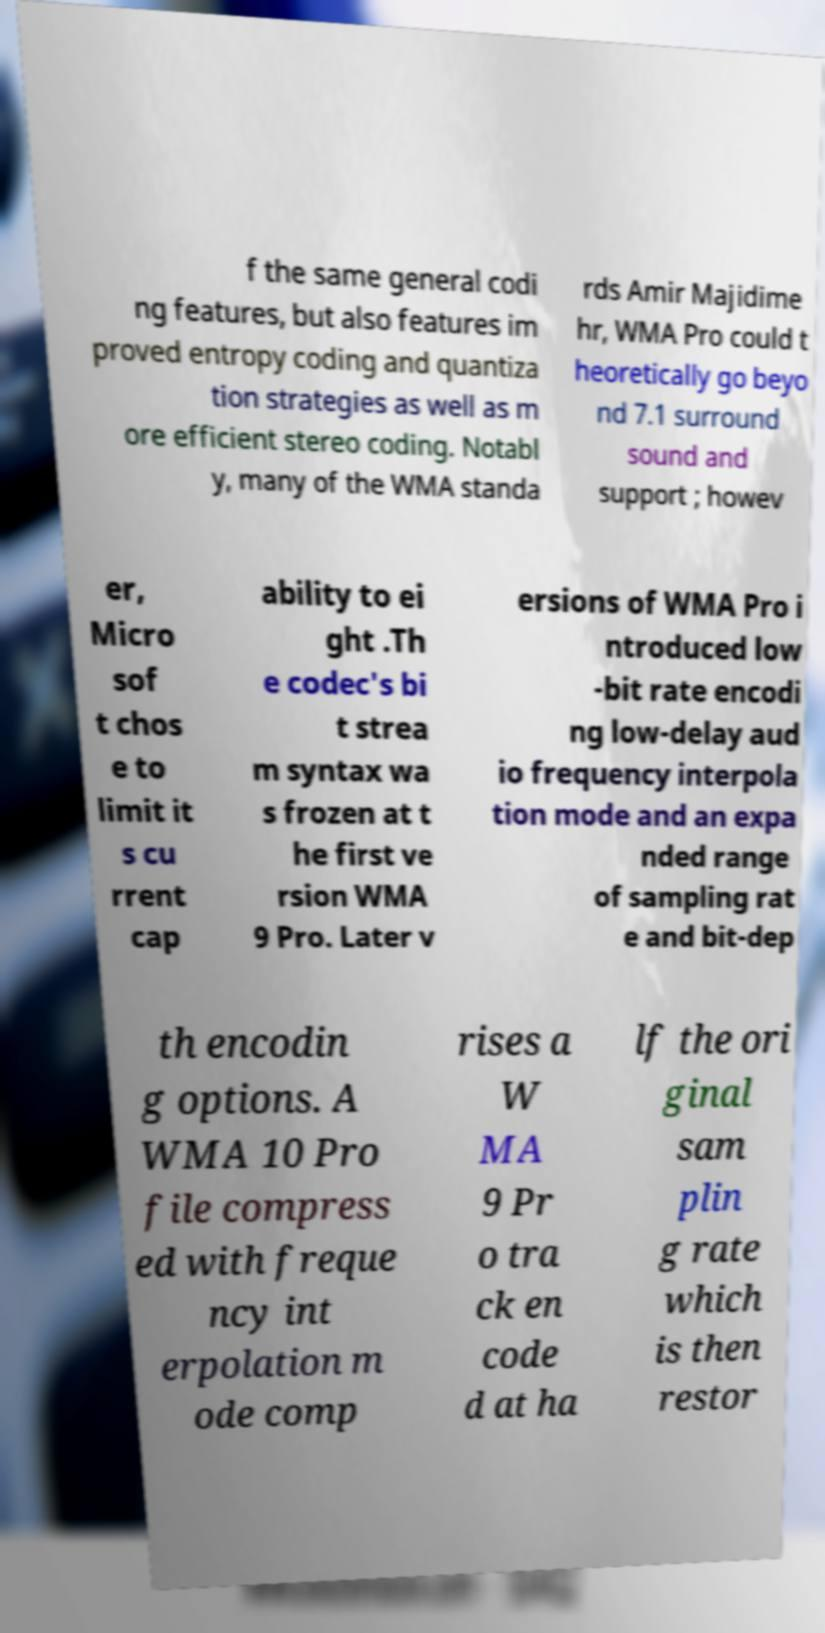There's text embedded in this image that I need extracted. Can you transcribe it verbatim? f the same general codi ng features, but also features im proved entropy coding and quantiza tion strategies as well as m ore efficient stereo coding. Notabl y, many of the WMA standa rds Amir Majidime hr, WMA Pro could t heoretically go beyo nd 7.1 surround sound and support ; howev er, Micro sof t chos e to limit it s cu rrent cap ability to ei ght .Th e codec's bi t strea m syntax wa s frozen at t he first ve rsion WMA 9 Pro. Later v ersions of WMA Pro i ntroduced low -bit rate encodi ng low-delay aud io frequency interpola tion mode and an expa nded range of sampling rat e and bit-dep th encodin g options. A WMA 10 Pro file compress ed with freque ncy int erpolation m ode comp rises a W MA 9 Pr o tra ck en code d at ha lf the ori ginal sam plin g rate which is then restor 